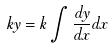Convert formula to latex. <formula><loc_0><loc_0><loc_500><loc_500>k y = k \int \frac { d y } { d x } d x</formula> 